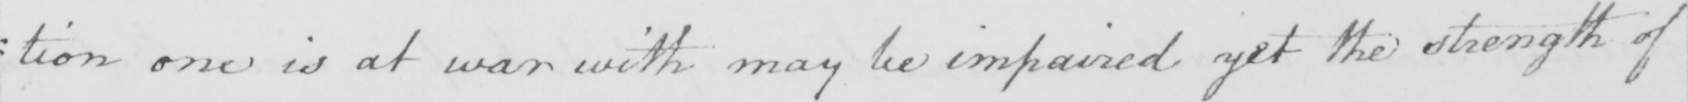What is written in this line of handwriting? : tion one is at war with may be impaired yet the strength of 